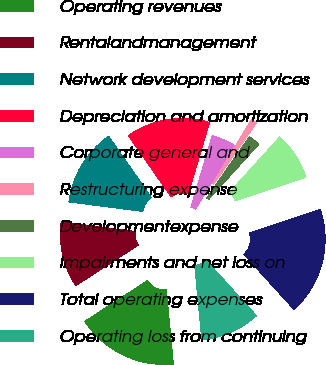<chart> <loc_0><loc_0><loc_500><loc_500><pie_chart><fcel>Operating revenues<fcel>Rentalandmanagement<fcel>Network development services<fcel>Depreciation and amortization<fcel>Corporate general and<fcel>Restructuring expense<fcel>Developmentexpense<fcel>Impairments and net loss on<fcel>Total operating expenses<fcel>Operating loss from continuing<nl><fcel>17.34%<fcel>11.22%<fcel>13.26%<fcel>14.28%<fcel>4.08%<fcel>1.02%<fcel>2.04%<fcel>8.16%<fcel>18.36%<fcel>10.2%<nl></chart> 